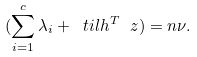<formula> <loc_0><loc_0><loc_500><loc_500>( \sum _ { i = 1 } ^ { c } \lambda _ { i } + \ t i l h ^ { T } \ z ) = n \nu .</formula> 